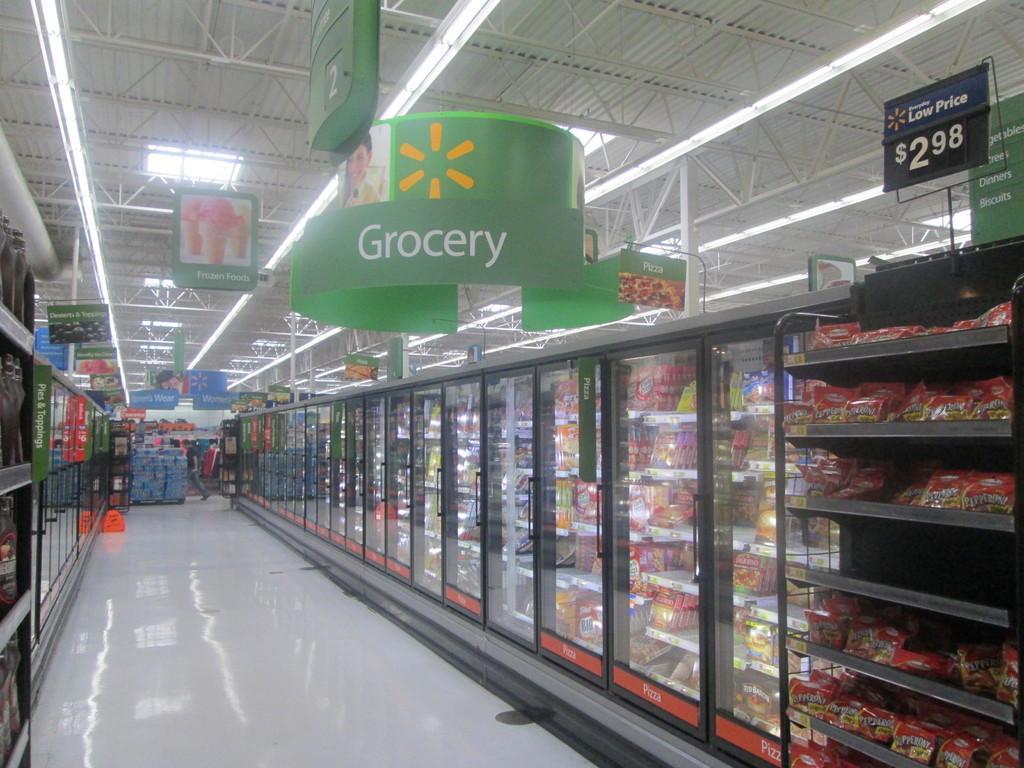In one or two sentences, can you explain what this image depicts? In this image we can see racks with packets and refrigerators with items on the right side. Also there is a price tag. And there are banners and lights on the ceiling. Also there are rods. On the left side there are shelves. In the back there are some items. Also there is a person walking. 